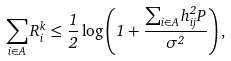Convert formula to latex. <formula><loc_0><loc_0><loc_500><loc_500>\sum _ { i \in A } R _ { i } ^ { k } \leq \frac { 1 } { 2 } \log \left ( 1 + \frac { \sum _ { i \in A } h ^ { 2 } _ { i j } P } { \sigma ^ { 2 } } \right ) ,</formula> 